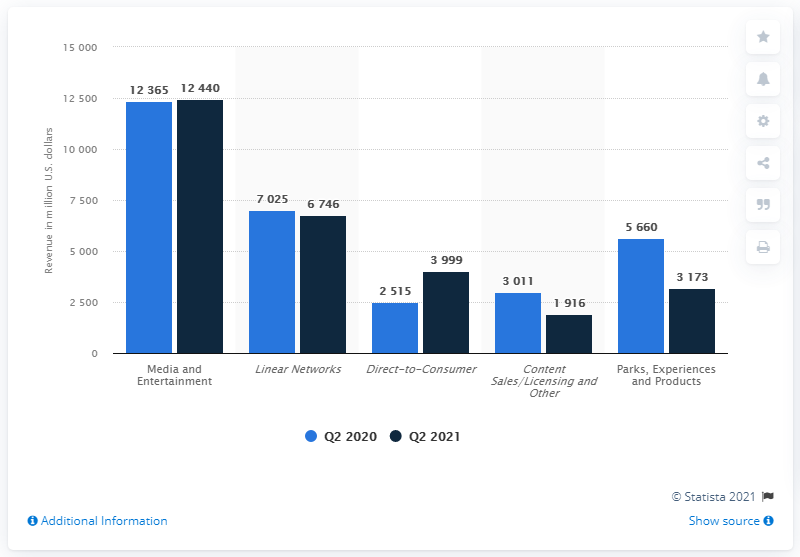List a handful of essential elements in this visual. The Walt Disney Company's media and entertainment segment generated approximately $12,365 in revenue in the second quarter of 2021. The revenue of the Media and Entertainment segment of Walt Disney Company showed the least change from the second quarter of 2020 to the second quarter of 2021, compared to the other segments. Linear Networks' revenue in Q2 2020 was approximately 7025 million U.S. dollars. 